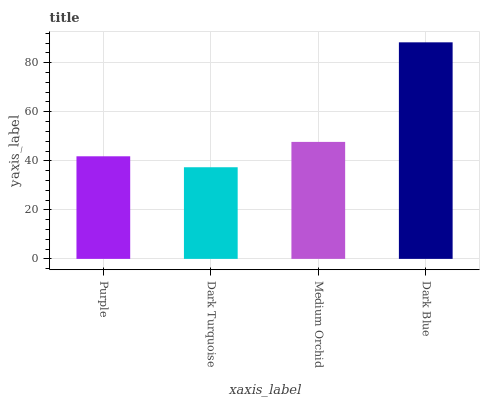Is Dark Turquoise the minimum?
Answer yes or no. Yes. Is Dark Blue the maximum?
Answer yes or no. Yes. Is Medium Orchid the minimum?
Answer yes or no. No. Is Medium Orchid the maximum?
Answer yes or no. No. Is Medium Orchid greater than Dark Turquoise?
Answer yes or no. Yes. Is Dark Turquoise less than Medium Orchid?
Answer yes or no. Yes. Is Dark Turquoise greater than Medium Orchid?
Answer yes or no. No. Is Medium Orchid less than Dark Turquoise?
Answer yes or no. No. Is Medium Orchid the high median?
Answer yes or no. Yes. Is Purple the low median?
Answer yes or no. Yes. Is Dark Blue the high median?
Answer yes or no. No. Is Medium Orchid the low median?
Answer yes or no. No. 